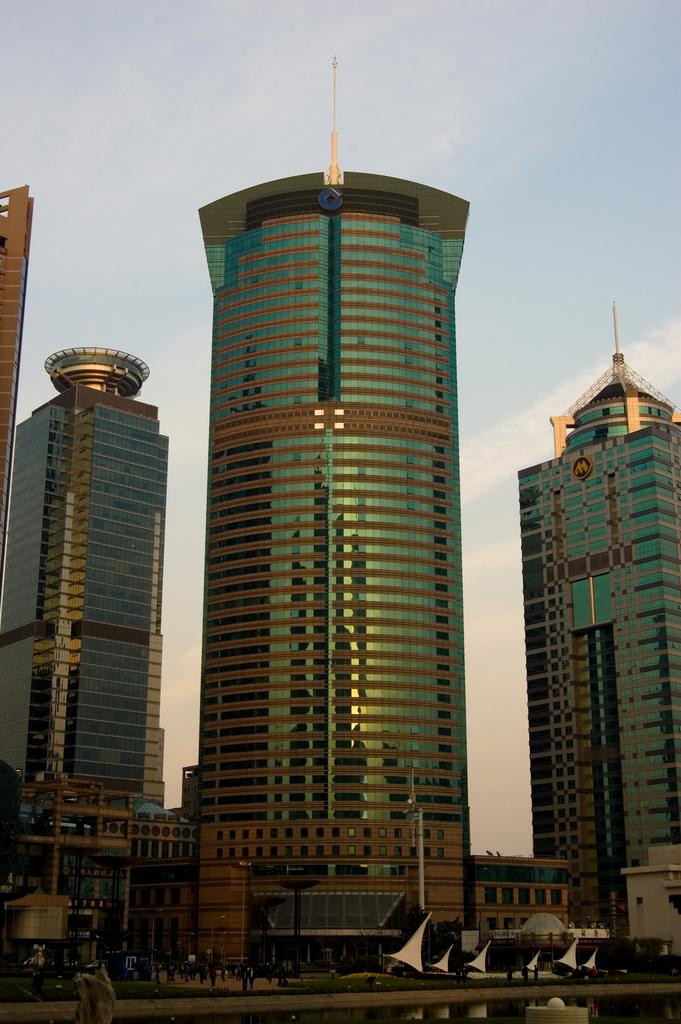What can be seen in the foreground of the image? There is a fencing in the image. What is visible in the background of the image? There are persons on the ground, grass, towers, and clouds in the blue sky in the background. Can you see a flock of bears in the image? There are no bears present in the image; it features a fencing and various elements in the background. 